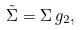Convert formula to latex. <formula><loc_0><loc_0><loc_500><loc_500>\tilde { \Sigma } = \Sigma \, g _ { 2 } ,</formula> 